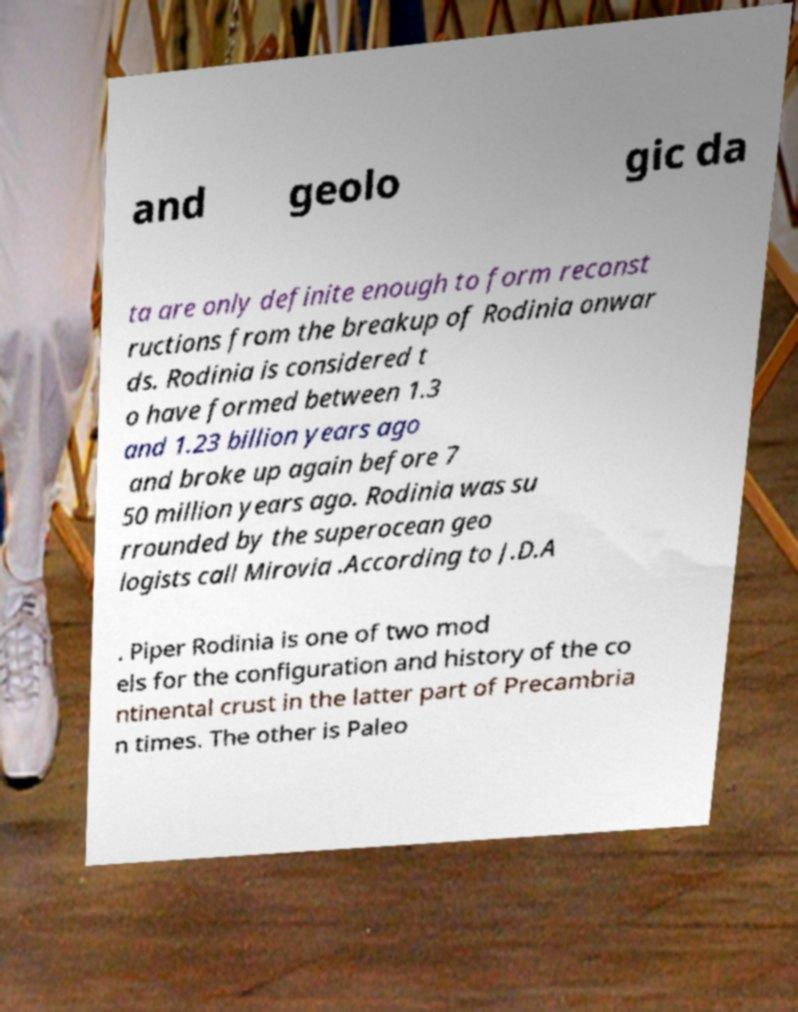Please read and relay the text visible in this image. What does it say? and geolo gic da ta are only definite enough to form reconst ructions from the breakup of Rodinia onwar ds. Rodinia is considered t o have formed between 1.3 and 1.23 billion years ago and broke up again before 7 50 million years ago. Rodinia was su rrounded by the superocean geo logists call Mirovia .According to J.D.A . Piper Rodinia is one of two mod els for the configuration and history of the co ntinental crust in the latter part of Precambria n times. The other is Paleo 